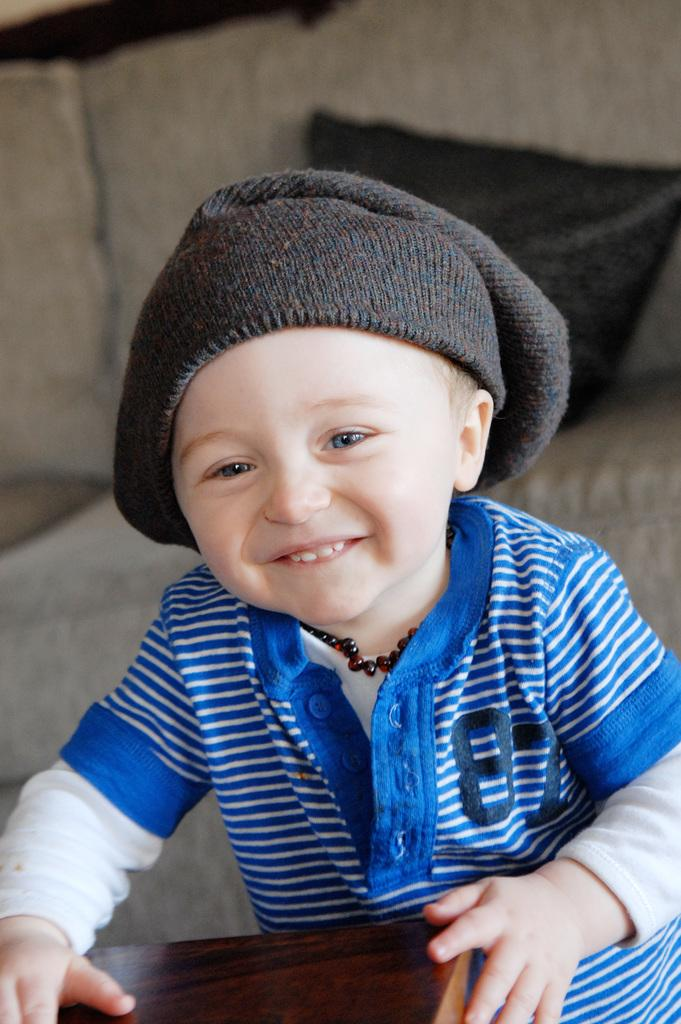What is the main subject of the image? The main subject of the image is a boy. What is the boy doing in the image? The boy is standing at a table and holding it. How is the boy's expression in the image? The boy is smiling in the image. What can be seen in the background of the image? There is a couch in the background of the image, and a pillow is on the couch. What type of carpenter tools can be seen in the image? There are no carpenter tools present in the image. What is the boy acting out in the image? The image does not depict the boy acting out a scene or role. 